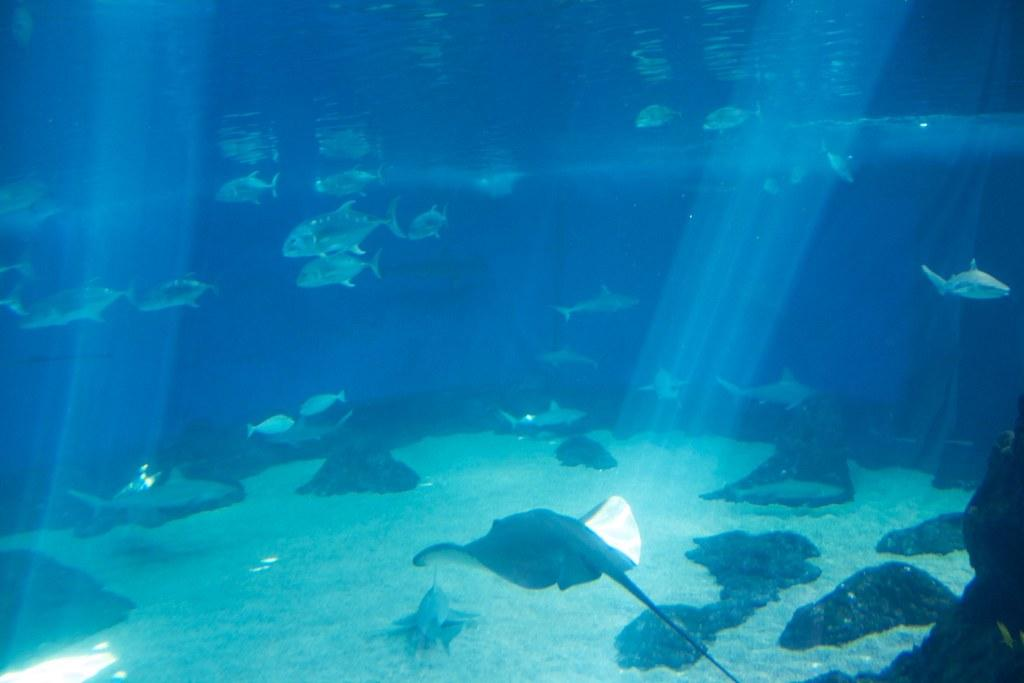What type of animals can be seen in the image? Fishes can be seen in the image. Where are the fishes located in the image? The fishes are in the middle of the image. What type of horn can be seen on the fishes in the image? There are no horns present on the fishes in the image. What type of bait is being used to catch the fishes in the image? There is no indication of any fishing activity or bait in the image, as it simply features fishes in the water. 